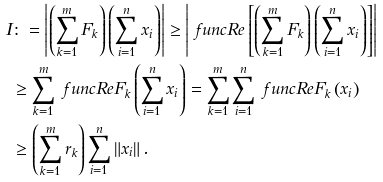<formula> <loc_0><loc_0><loc_500><loc_500>I & \colon = \left | \left ( \sum _ { k = 1 } ^ { m } F _ { k } \right ) \left ( \sum _ { i = 1 } ^ { n } x _ { i } \right ) \right | \geq \left | \ f u n c { R e } \left [ \left ( \sum _ { k = 1 } ^ { m } F _ { k } \right ) \left ( \sum _ { i = 1 } ^ { n } x _ { i } \right ) \right ] \right | \\ & \geq \sum _ { k = 1 } ^ { m } \ f u n c { R e } F _ { k } \left ( \sum _ { i = 1 } ^ { n } x _ { i } \right ) = \sum _ { k = 1 } ^ { m } \sum _ { i = 1 } ^ { n } \ f u n c { R e } F _ { k } \left ( x _ { i } \right ) \\ & \geq \left ( \sum _ { k = 1 } ^ { m } r _ { k } \right ) \sum _ { i = 1 } ^ { n } \left \| x _ { i } \right \| .</formula> 